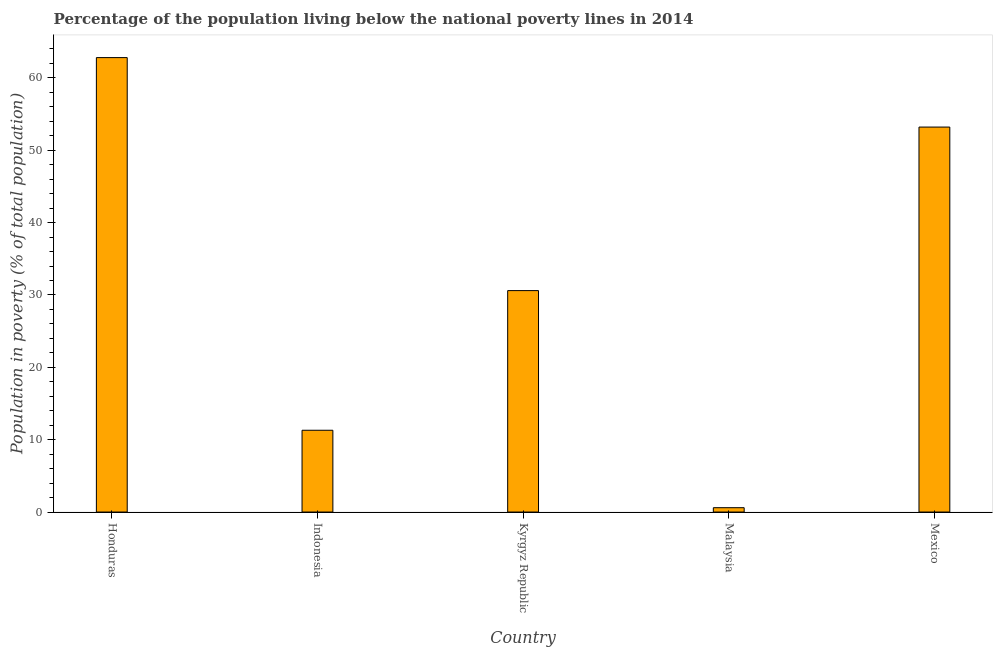What is the title of the graph?
Give a very brief answer. Percentage of the population living below the national poverty lines in 2014. What is the label or title of the Y-axis?
Provide a succinct answer. Population in poverty (% of total population). What is the percentage of population living below poverty line in Kyrgyz Republic?
Give a very brief answer. 30.6. Across all countries, what is the maximum percentage of population living below poverty line?
Your response must be concise. 62.8. In which country was the percentage of population living below poverty line maximum?
Give a very brief answer. Honduras. In which country was the percentage of population living below poverty line minimum?
Your answer should be compact. Malaysia. What is the sum of the percentage of population living below poverty line?
Your response must be concise. 158.5. What is the difference between the percentage of population living below poverty line in Indonesia and Malaysia?
Offer a terse response. 10.7. What is the average percentage of population living below poverty line per country?
Ensure brevity in your answer.  31.7. What is the median percentage of population living below poverty line?
Your response must be concise. 30.6. In how many countries, is the percentage of population living below poverty line greater than 24 %?
Give a very brief answer. 3. What is the ratio of the percentage of population living below poverty line in Honduras to that in Malaysia?
Your answer should be compact. 104.67. What is the difference between the highest and the lowest percentage of population living below poverty line?
Your response must be concise. 62.2. How many bars are there?
Offer a terse response. 5. Are all the bars in the graph horizontal?
Give a very brief answer. No. How many countries are there in the graph?
Offer a terse response. 5. What is the difference between two consecutive major ticks on the Y-axis?
Offer a very short reply. 10. What is the Population in poverty (% of total population) of Honduras?
Offer a very short reply. 62.8. What is the Population in poverty (% of total population) of Kyrgyz Republic?
Your answer should be compact. 30.6. What is the Population in poverty (% of total population) in Malaysia?
Provide a succinct answer. 0.6. What is the Population in poverty (% of total population) in Mexico?
Give a very brief answer. 53.2. What is the difference between the Population in poverty (% of total population) in Honduras and Indonesia?
Your answer should be very brief. 51.5. What is the difference between the Population in poverty (% of total population) in Honduras and Kyrgyz Republic?
Your answer should be very brief. 32.2. What is the difference between the Population in poverty (% of total population) in Honduras and Malaysia?
Your answer should be very brief. 62.2. What is the difference between the Population in poverty (% of total population) in Honduras and Mexico?
Ensure brevity in your answer.  9.6. What is the difference between the Population in poverty (% of total population) in Indonesia and Kyrgyz Republic?
Give a very brief answer. -19.3. What is the difference between the Population in poverty (% of total population) in Indonesia and Mexico?
Give a very brief answer. -41.9. What is the difference between the Population in poverty (% of total population) in Kyrgyz Republic and Malaysia?
Your response must be concise. 30. What is the difference between the Population in poverty (% of total population) in Kyrgyz Republic and Mexico?
Your response must be concise. -22.6. What is the difference between the Population in poverty (% of total population) in Malaysia and Mexico?
Offer a terse response. -52.6. What is the ratio of the Population in poverty (% of total population) in Honduras to that in Indonesia?
Make the answer very short. 5.56. What is the ratio of the Population in poverty (% of total population) in Honduras to that in Kyrgyz Republic?
Provide a succinct answer. 2.05. What is the ratio of the Population in poverty (% of total population) in Honduras to that in Malaysia?
Keep it short and to the point. 104.67. What is the ratio of the Population in poverty (% of total population) in Honduras to that in Mexico?
Provide a succinct answer. 1.18. What is the ratio of the Population in poverty (% of total population) in Indonesia to that in Kyrgyz Republic?
Your answer should be very brief. 0.37. What is the ratio of the Population in poverty (% of total population) in Indonesia to that in Malaysia?
Keep it short and to the point. 18.83. What is the ratio of the Population in poverty (% of total population) in Indonesia to that in Mexico?
Provide a succinct answer. 0.21. What is the ratio of the Population in poverty (% of total population) in Kyrgyz Republic to that in Mexico?
Provide a short and direct response. 0.57. What is the ratio of the Population in poverty (% of total population) in Malaysia to that in Mexico?
Offer a terse response. 0.01. 